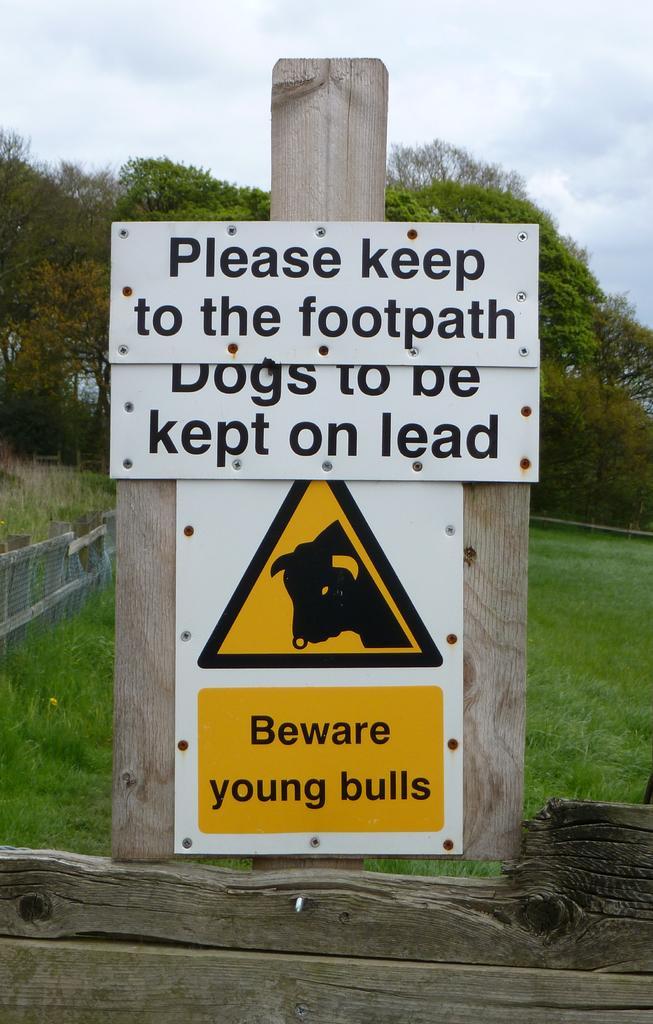Please provide a concise description of this image. In this image I can see the board attached to the wooden pole. In the background I can see the grass and few plants in green color and the sky is in white color. 